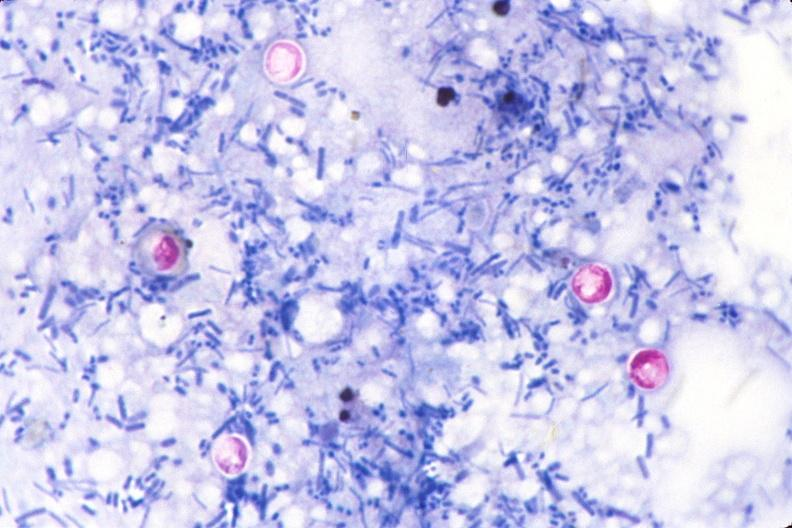s gastrointestinal present?
Answer the question using a single word or phrase. Yes 